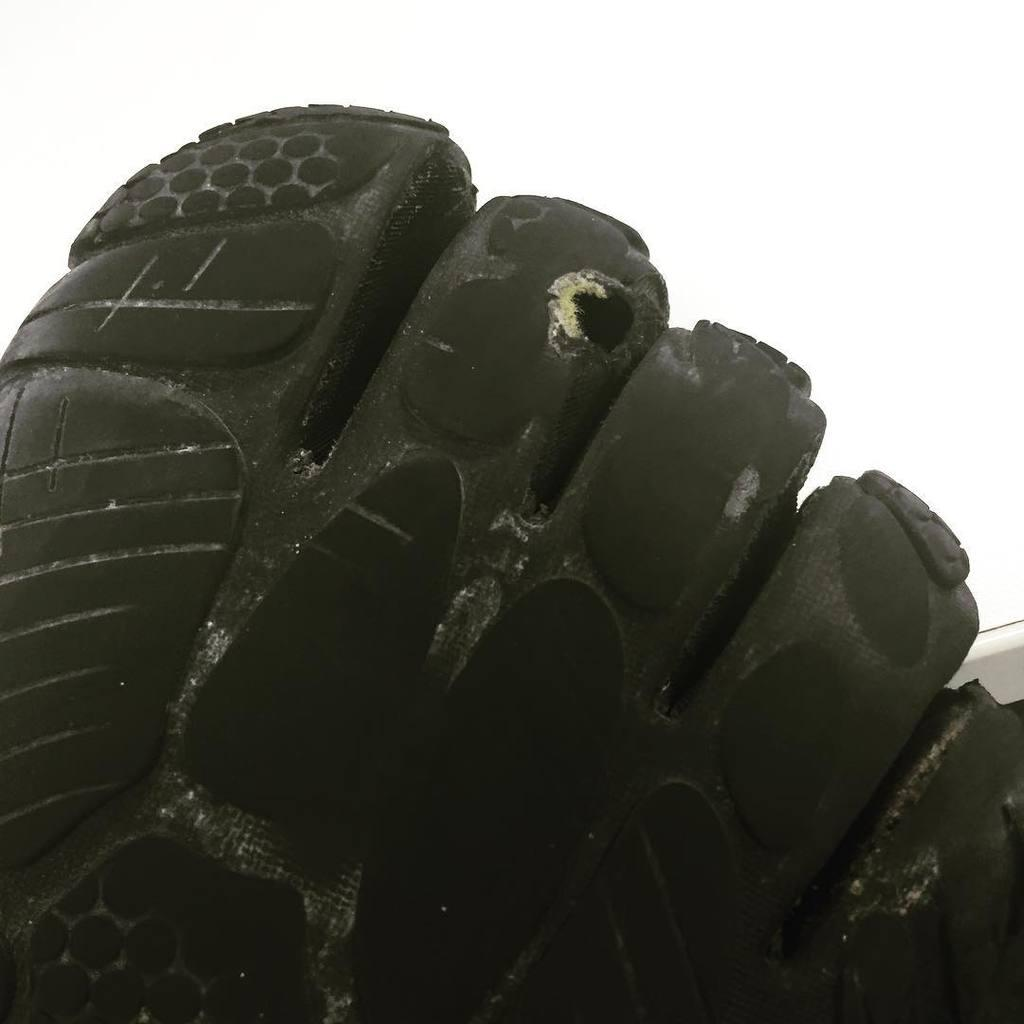What is the main subject of the image? The main subject of the image is a foot-shaped object. What can you tell about the material used to make the foot-shaped object? The foot-shaped object is made with some material, but the specific material is not mentioned in the facts. What color is the background of the image? The background of the image is white. What type of egg is being used as a relation tool in the image? There is no egg or relation tool present in the image; it only features a foot-shaped object and a white background. 